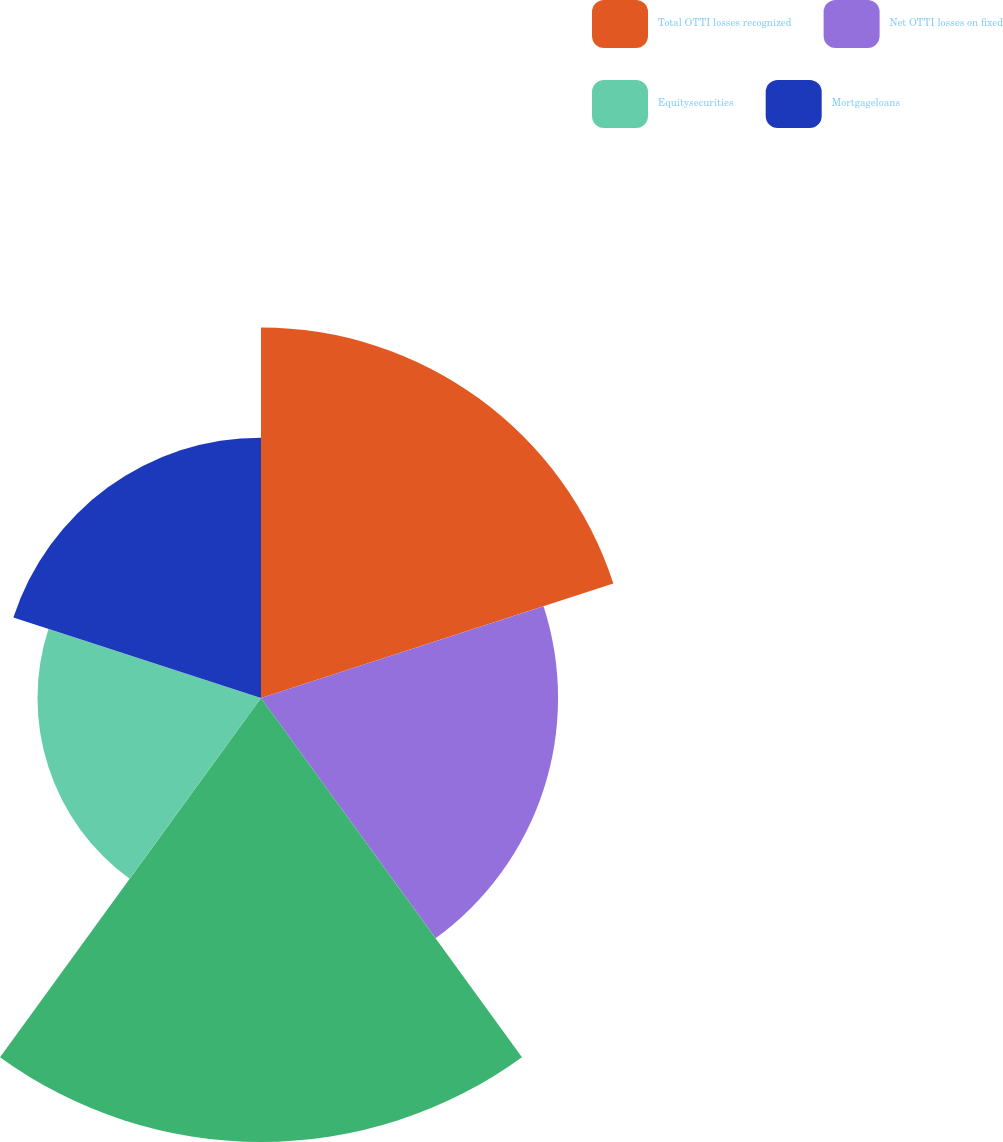<chart> <loc_0><loc_0><loc_500><loc_500><pie_chart><fcel>Total OTTI losses recognized<fcel>Net OTTI losses on fixed<fcel>Unnamed: 2<fcel>Equitysecurities<fcel>Mortgageloans<nl><fcel>23.22%<fcel>18.62%<fcel>27.83%<fcel>14.01%<fcel>16.32%<nl></chart> 